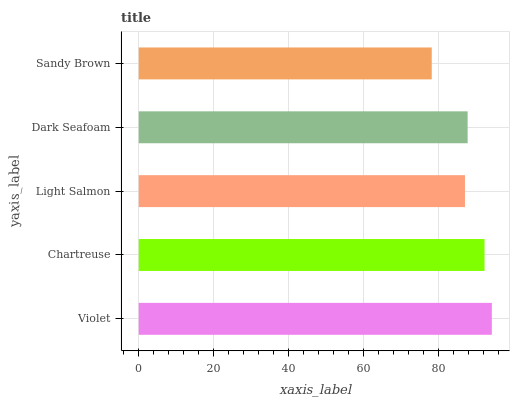Is Sandy Brown the minimum?
Answer yes or no. Yes. Is Violet the maximum?
Answer yes or no. Yes. Is Chartreuse the minimum?
Answer yes or no. No. Is Chartreuse the maximum?
Answer yes or no. No. Is Violet greater than Chartreuse?
Answer yes or no. Yes. Is Chartreuse less than Violet?
Answer yes or no. Yes. Is Chartreuse greater than Violet?
Answer yes or no. No. Is Violet less than Chartreuse?
Answer yes or no. No. Is Dark Seafoam the high median?
Answer yes or no. Yes. Is Dark Seafoam the low median?
Answer yes or no. Yes. Is Chartreuse the high median?
Answer yes or no. No. Is Violet the low median?
Answer yes or no. No. 